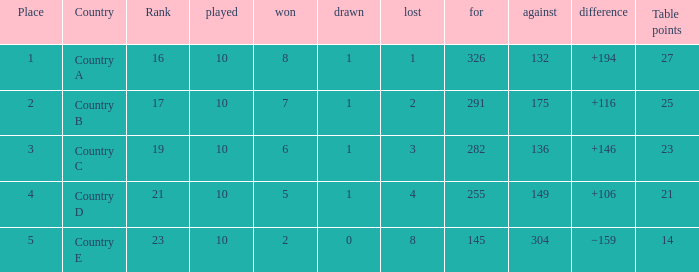 How many games had a deficit of 175?  1.0. 